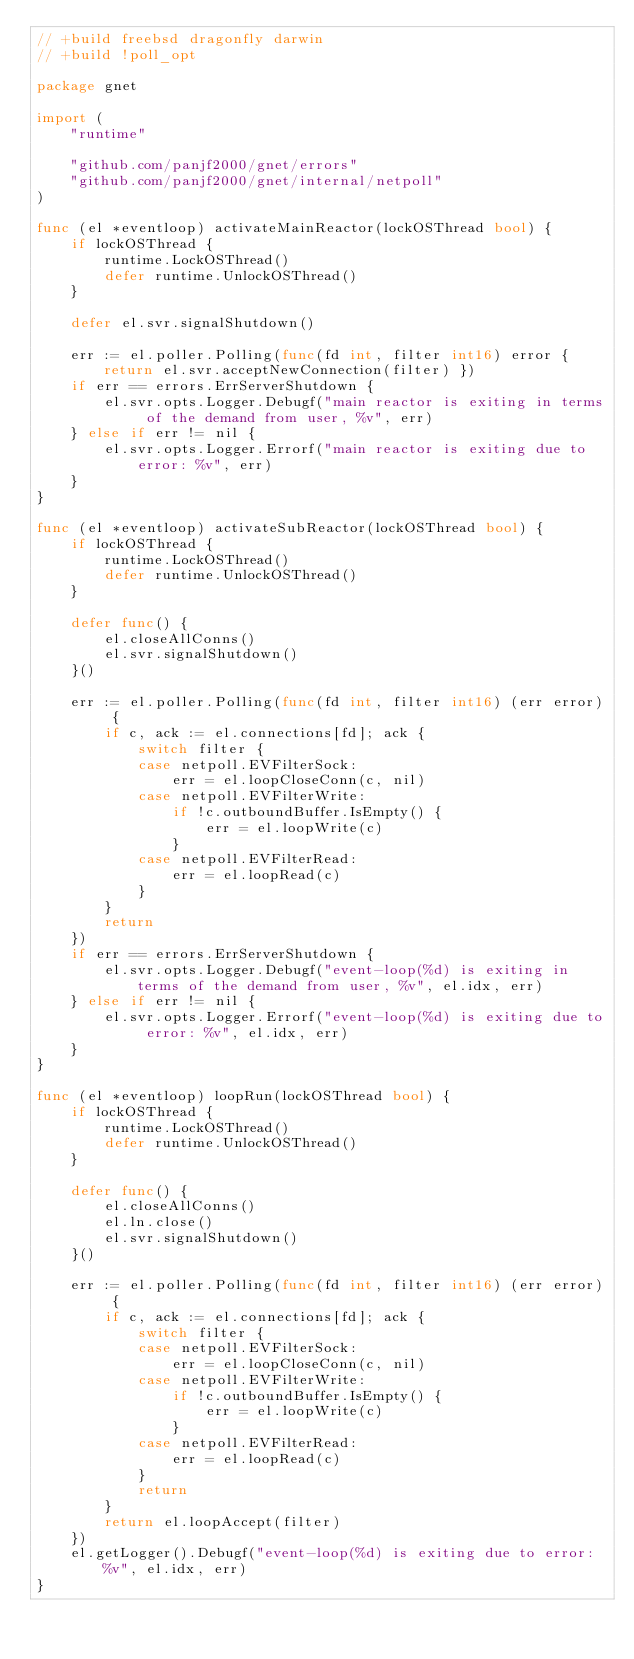Convert code to text. <code><loc_0><loc_0><loc_500><loc_500><_Go_>// +build freebsd dragonfly darwin
// +build !poll_opt

package gnet

import (
	"runtime"

	"github.com/panjf2000/gnet/errors"
	"github.com/panjf2000/gnet/internal/netpoll"
)

func (el *eventloop) activateMainReactor(lockOSThread bool) {
	if lockOSThread {
		runtime.LockOSThread()
		defer runtime.UnlockOSThread()
	}

	defer el.svr.signalShutdown()

	err := el.poller.Polling(func(fd int, filter int16) error { return el.svr.acceptNewConnection(filter) })
	if err == errors.ErrServerShutdown {
		el.svr.opts.Logger.Debugf("main reactor is exiting in terms of the demand from user, %v", err)
	} else if err != nil {
		el.svr.opts.Logger.Errorf("main reactor is exiting due to error: %v", err)
	}
}

func (el *eventloop) activateSubReactor(lockOSThread bool) {
	if lockOSThread {
		runtime.LockOSThread()
		defer runtime.UnlockOSThread()
	}

	defer func() {
		el.closeAllConns()
		el.svr.signalShutdown()
	}()

	err := el.poller.Polling(func(fd int, filter int16) (err error) {
		if c, ack := el.connections[fd]; ack {
			switch filter {
			case netpoll.EVFilterSock:
				err = el.loopCloseConn(c, nil)
			case netpoll.EVFilterWrite:
				if !c.outboundBuffer.IsEmpty() {
					err = el.loopWrite(c)
				}
			case netpoll.EVFilterRead:
				err = el.loopRead(c)
			}
		}
		return
	})
	if err == errors.ErrServerShutdown {
		el.svr.opts.Logger.Debugf("event-loop(%d) is exiting in terms of the demand from user, %v", el.idx, err)
	} else if err != nil {
		el.svr.opts.Logger.Errorf("event-loop(%d) is exiting due to error: %v", el.idx, err)
	}
}

func (el *eventloop) loopRun(lockOSThread bool) {
	if lockOSThread {
		runtime.LockOSThread()
		defer runtime.UnlockOSThread()
	}

	defer func() {
		el.closeAllConns()
		el.ln.close()
		el.svr.signalShutdown()
	}()

	err := el.poller.Polling(func(fd int, filter int16) (err error) {
		if c, ack := el.connections[fd]; ack {
			switch filter {
			case netpoll.EVFilterSock:
				err = el.loopCloseConn(c, nil)
			case netpoll.EVFilterWrite:
				if !c.outboundBuffer.IsEmpty() {
					err = el.loopWrite(c)
				}
			case netpoll.EVFilterRead:
				err = el.loopRead(c)
			}
			return
		}
		return el.loopAccept(filter)
	})
	el.getLogger().Debugf("event-loop(%d) is exiting due to error: %v", el.idx, err)
}
</code> 